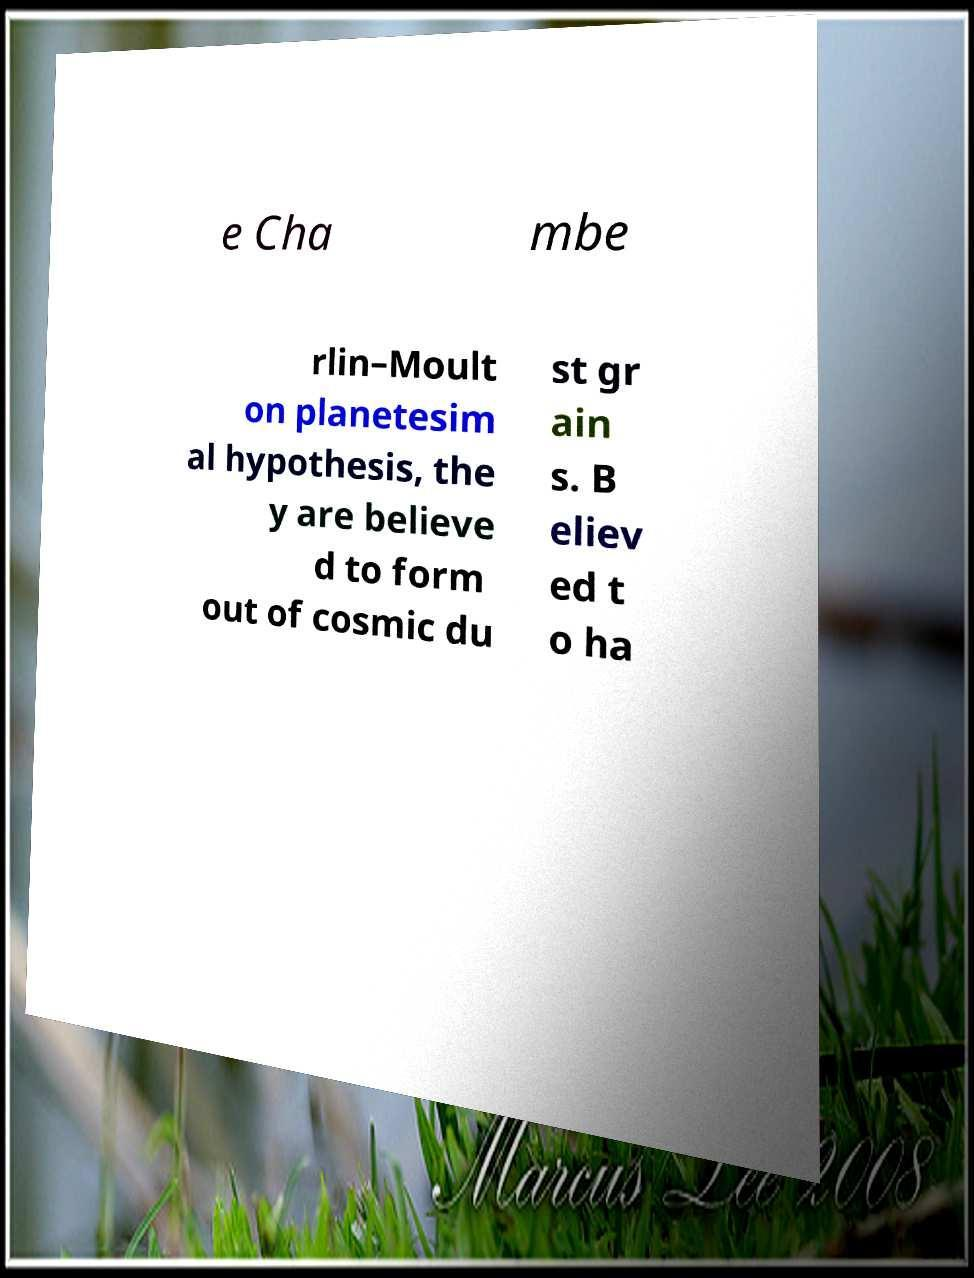There's text embedded in this image that I need extracted. Can you transcribe it verbatim? e Cha mbe rlin–Moult on planetesim al hypothesis, the y are believe d to form out of cosmic du st gr ain s. B eliev ed t o ha 